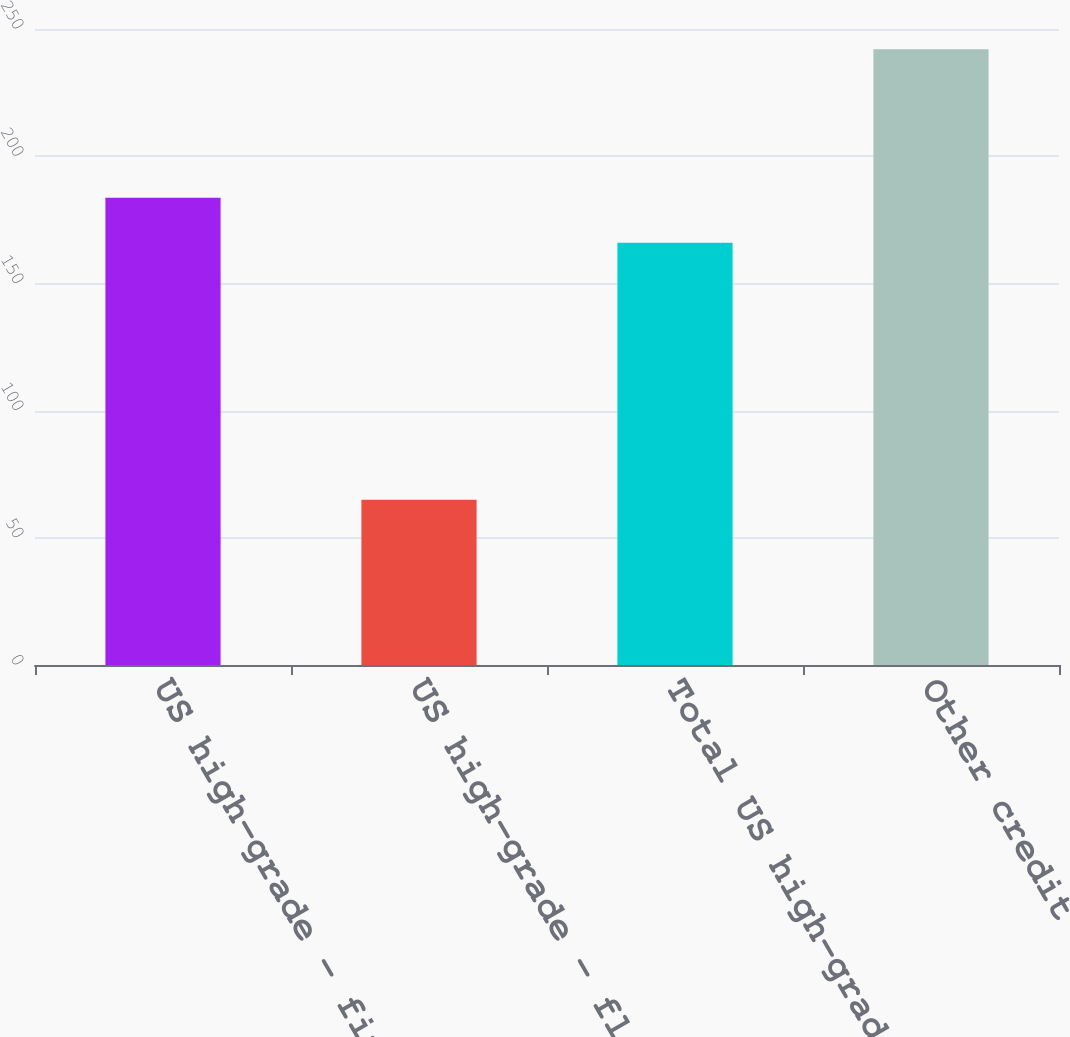Convert chart. <chart><loc_0><loc_0><loc_500><loc_500><bar_chart><fcel>US high-grade - fixed rate<fcel>US high-grade - floating rate<fcel>Total US high-grade<fcel>Other credit<nl><fcel>183.7<fcel>65<fcel>166<fcel>242<nl></chart> 